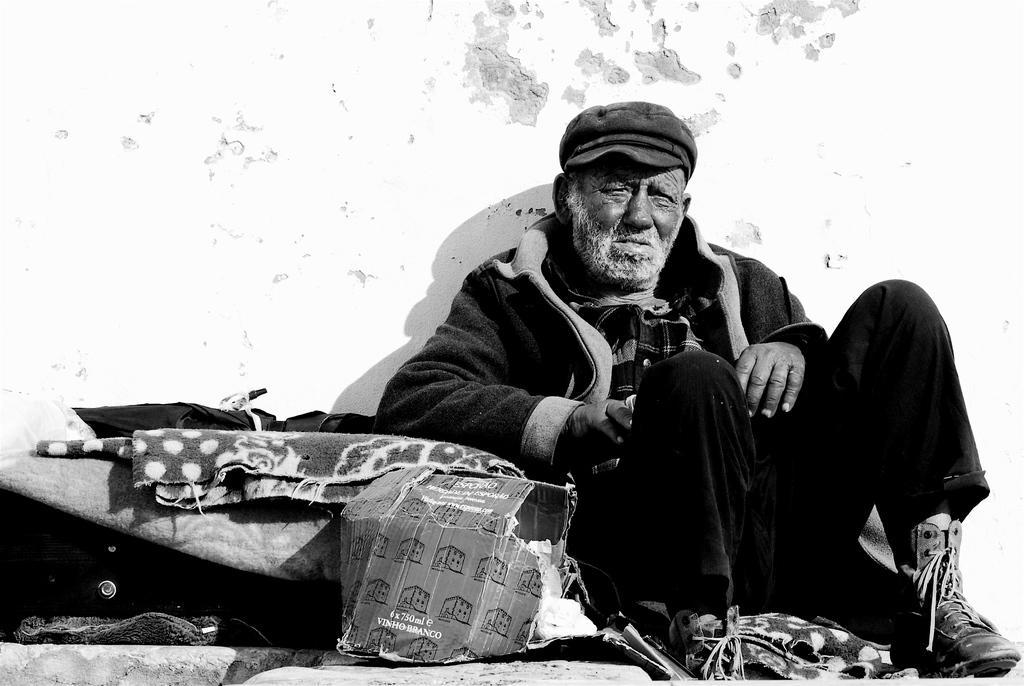Can you describe this image briefly? In the image in the center,we can see one man sitting. And we can see boxes,blankets and few other objects. In the background there is a wall. 